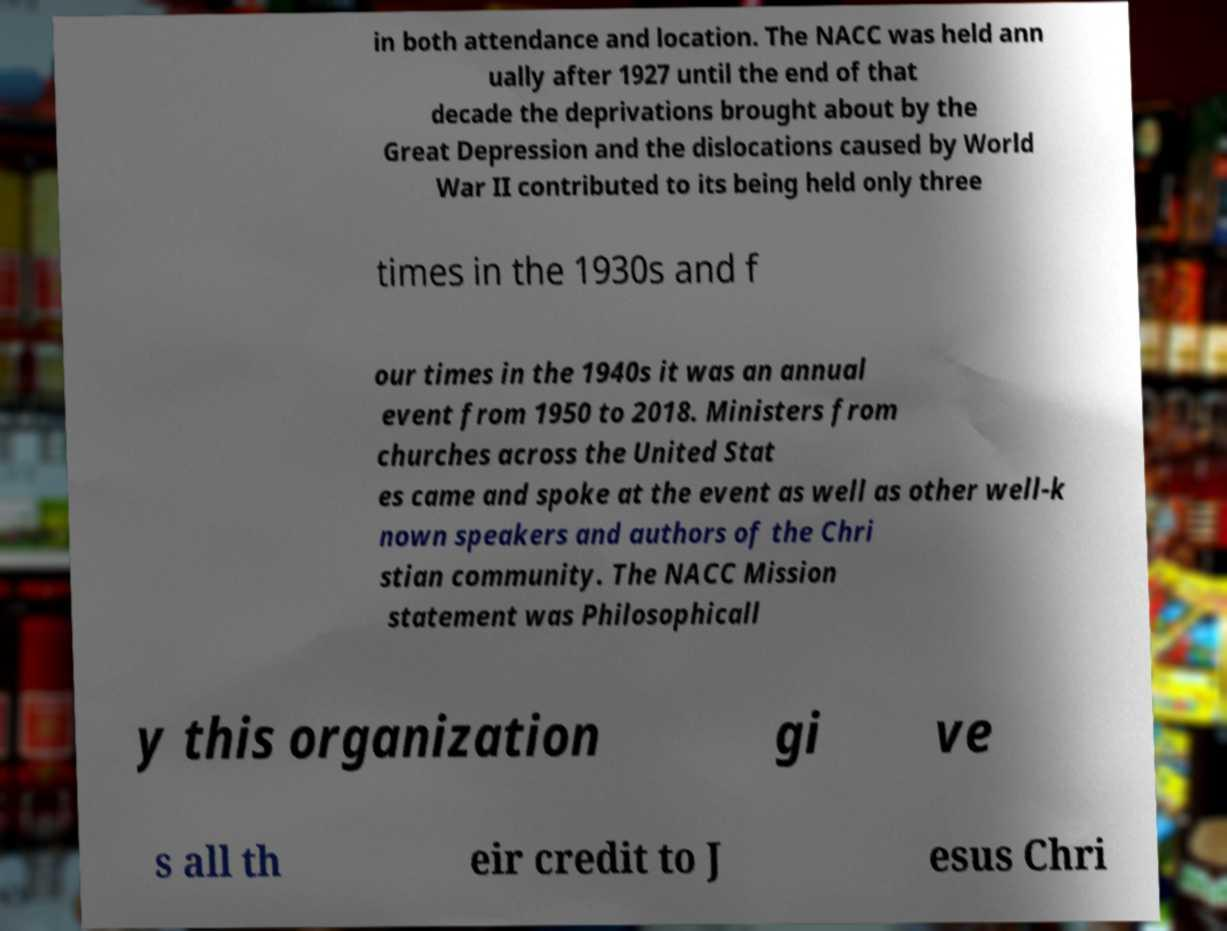Please identify and transcribe the text found in this image. in both attendance and location. The NACC was held ann ually after 1927 until the end of that decade the deprivations brought about by the Great Depression and the dislocations caused by World War II contributed to its being held only three times in the 1930s and f our times in the 1940s it was an annual event from 1950 to 2018. Ministers from churches across the United Stat es came and spoke at the event as well as other well-k nown speakers and authors of the Chri stian community. The NACC Mission statement was Philosophicall y this organization gi ve s all th eir credit to J esus Chri 